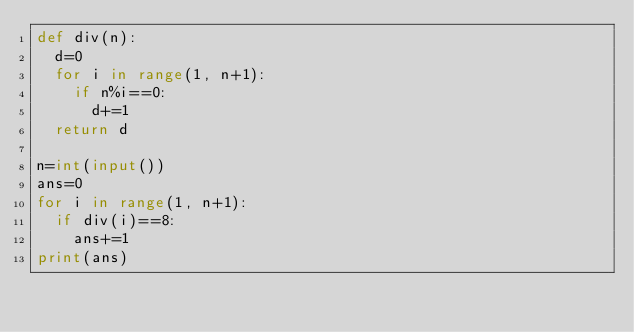Convert code to text. <code><loc_0><loc_0><loc_500><loc_500><_Python_>def div(n):
  d=0
  for i in range(1, n+1):
    if n%i==0:
      d+=1
  return d

n=int(input())
ans=0
for i in range(1, n+1):
  if div(i)==8:
    ans+=1
print(ans)</code> 